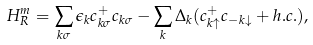<formula> <loc_0><loc_0><loc_500><loc_500>H _ { R } ^ { m } = \sum _ { k \sigma } \epsilon _ { k } c _ { k \sigma } ^ { + } c _ { k \sigma } - \sum _ { k } \Delta _ { k } ( c _ { k \uparrow } ^ { + } c _ { - k \downarrow } + h . c . ) ,</formula> 